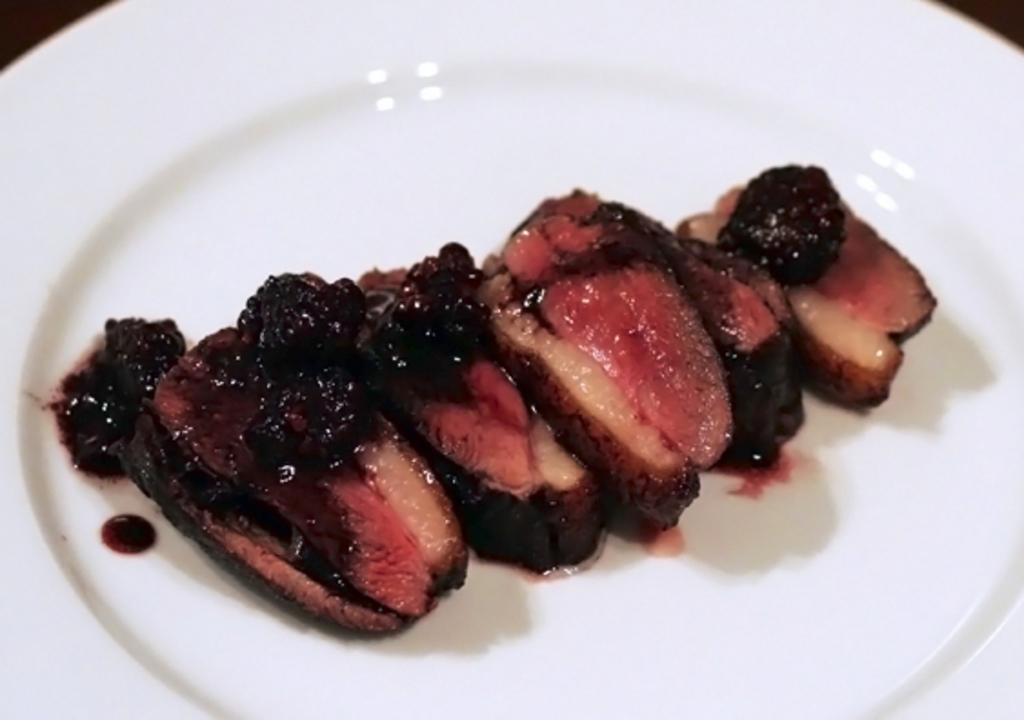What is the main object in the center of the image? There is a white color palette in the image, and it is in the center. What is on the palette? The palette contains food items. What type of list can be seen on the palette? There is no list present on the palette; it contains food items. Can you tell me the name of the father in the image? There is no person or father mentioned or depicted in the image. 